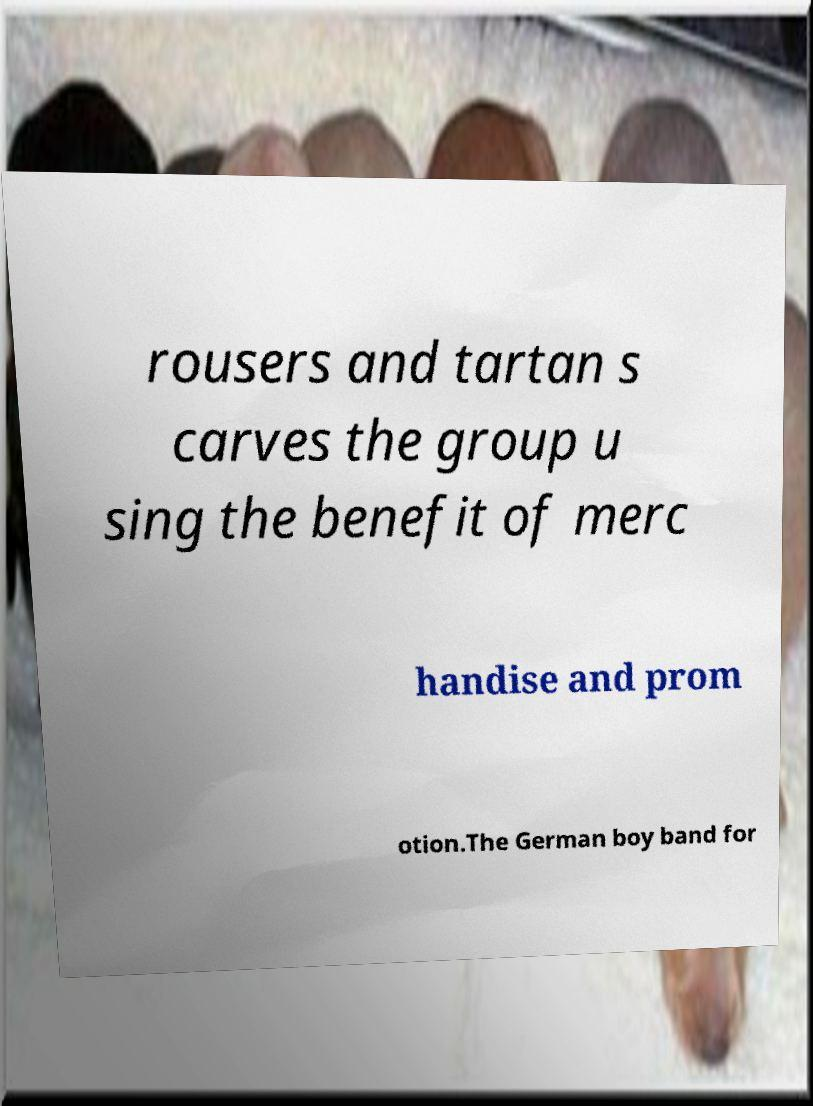Please identify and transcribe the text found in this image. rousers and tartan s carves the group u sing the benefit of merc handise and prom otion.The German boy band for 